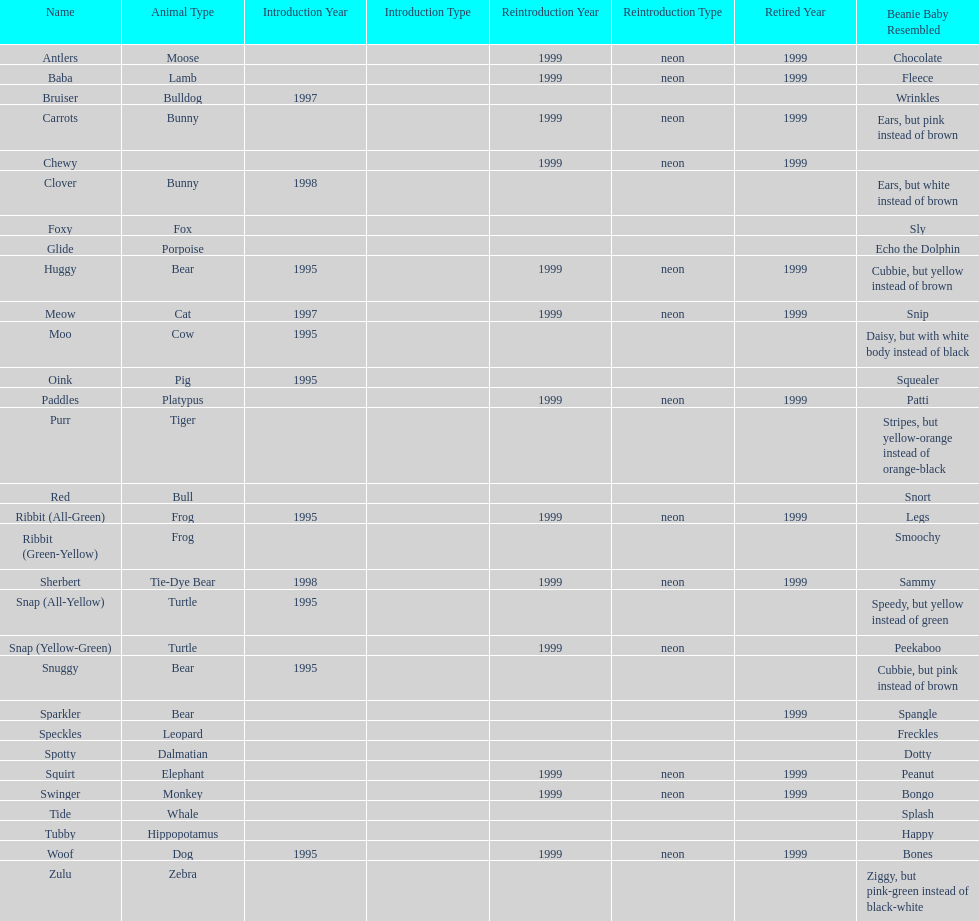What is the number of frog pillow pals? 2. 